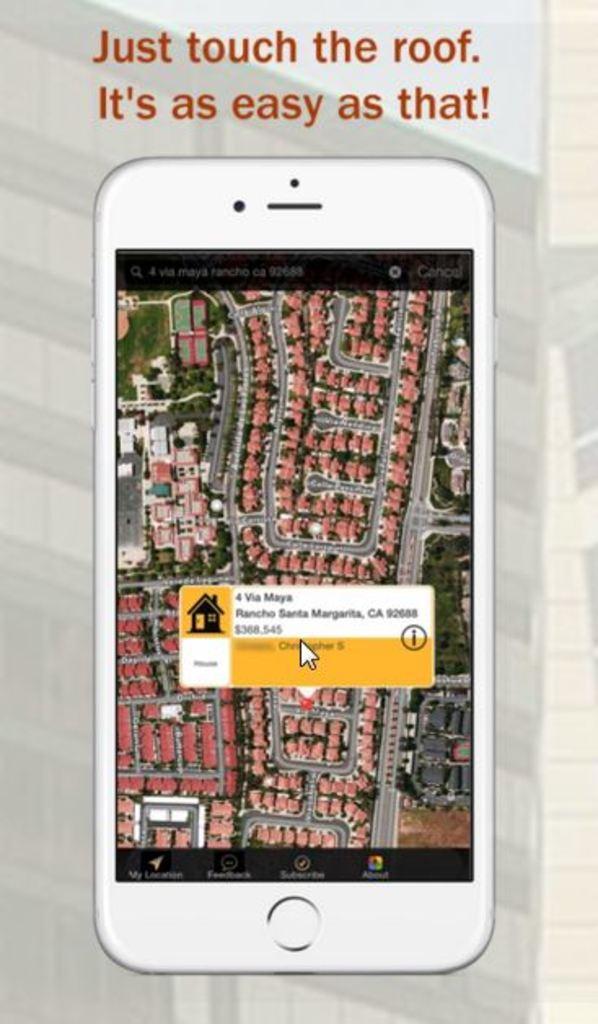Could you give a brief overview of what you see in this image? This image consists of a poster with an image of a mobile phone and there is a text on it. On the screen there is a map. 